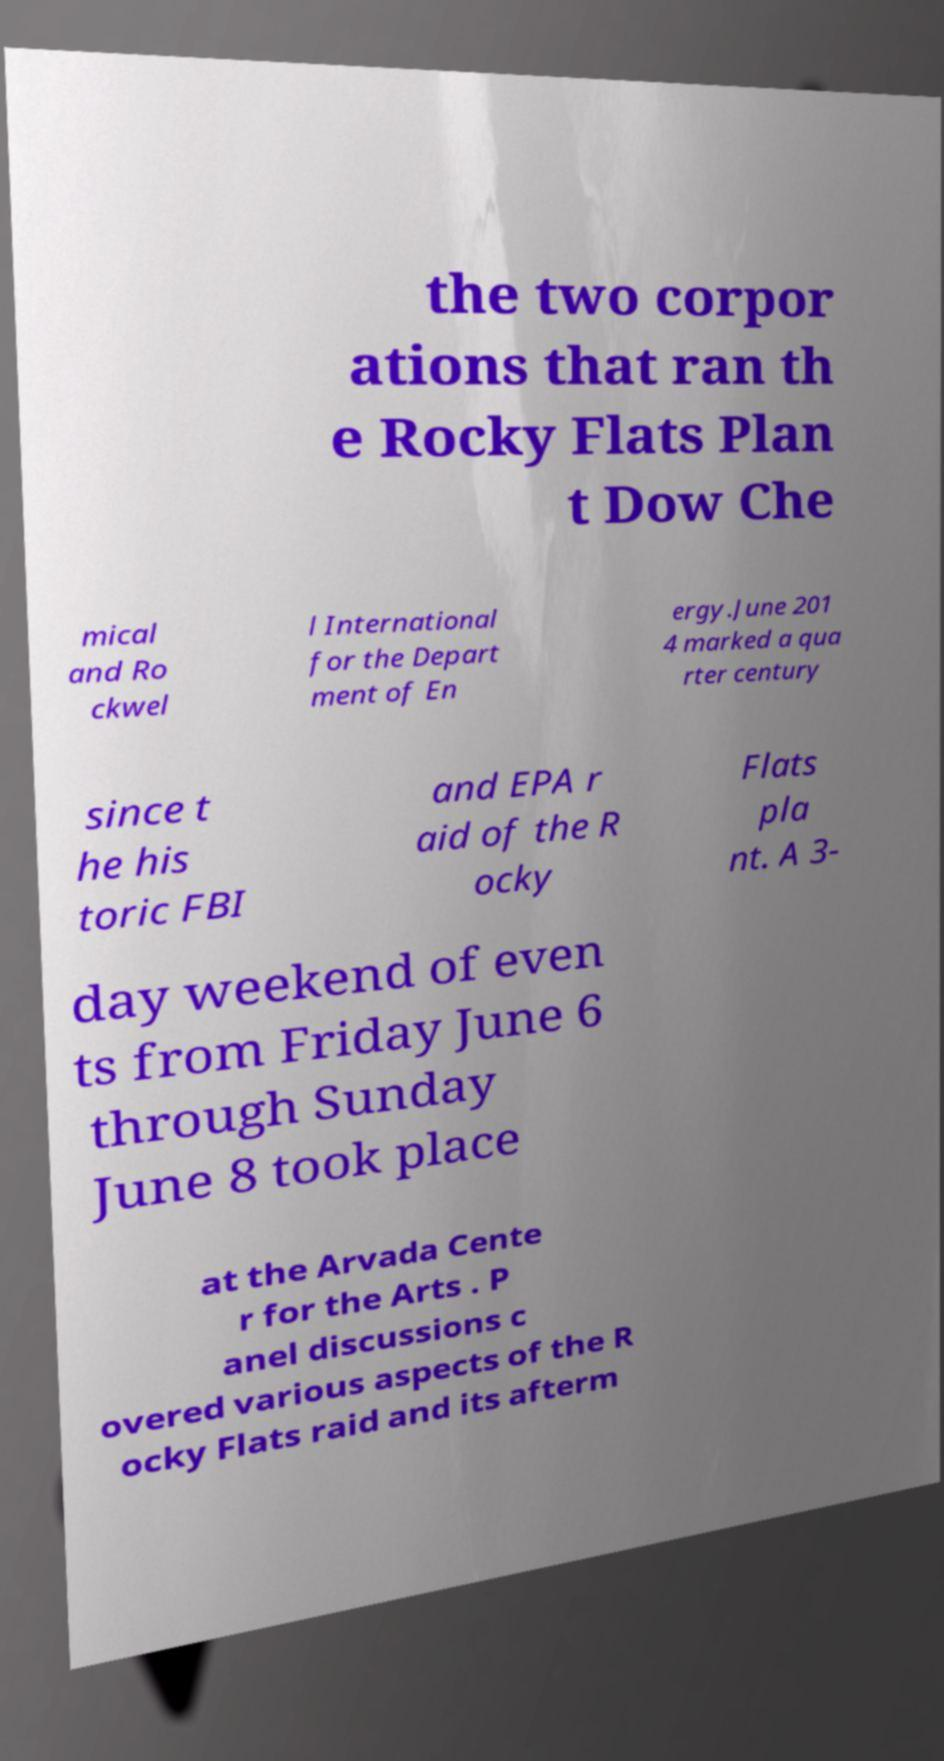There's text embedded in this image that I need extracted. Can you transcribe it verbatim? the two corpor ations that ran th e Rocky Flats Plan t Dow Che mical and Ro ckwel l International for the Depart ment of En ergy.June 201 4 marked a qua rter century since t he his toric FBI and EPA r aid of the R ocky Flats pla nt. A 3- day weekend of even ts from Friday June 6 through Sunday June 8 took place at the Arvada Cente r for the Arts . P anel discussions c overed various aspects of the R ocky Flats raid and its afterm 